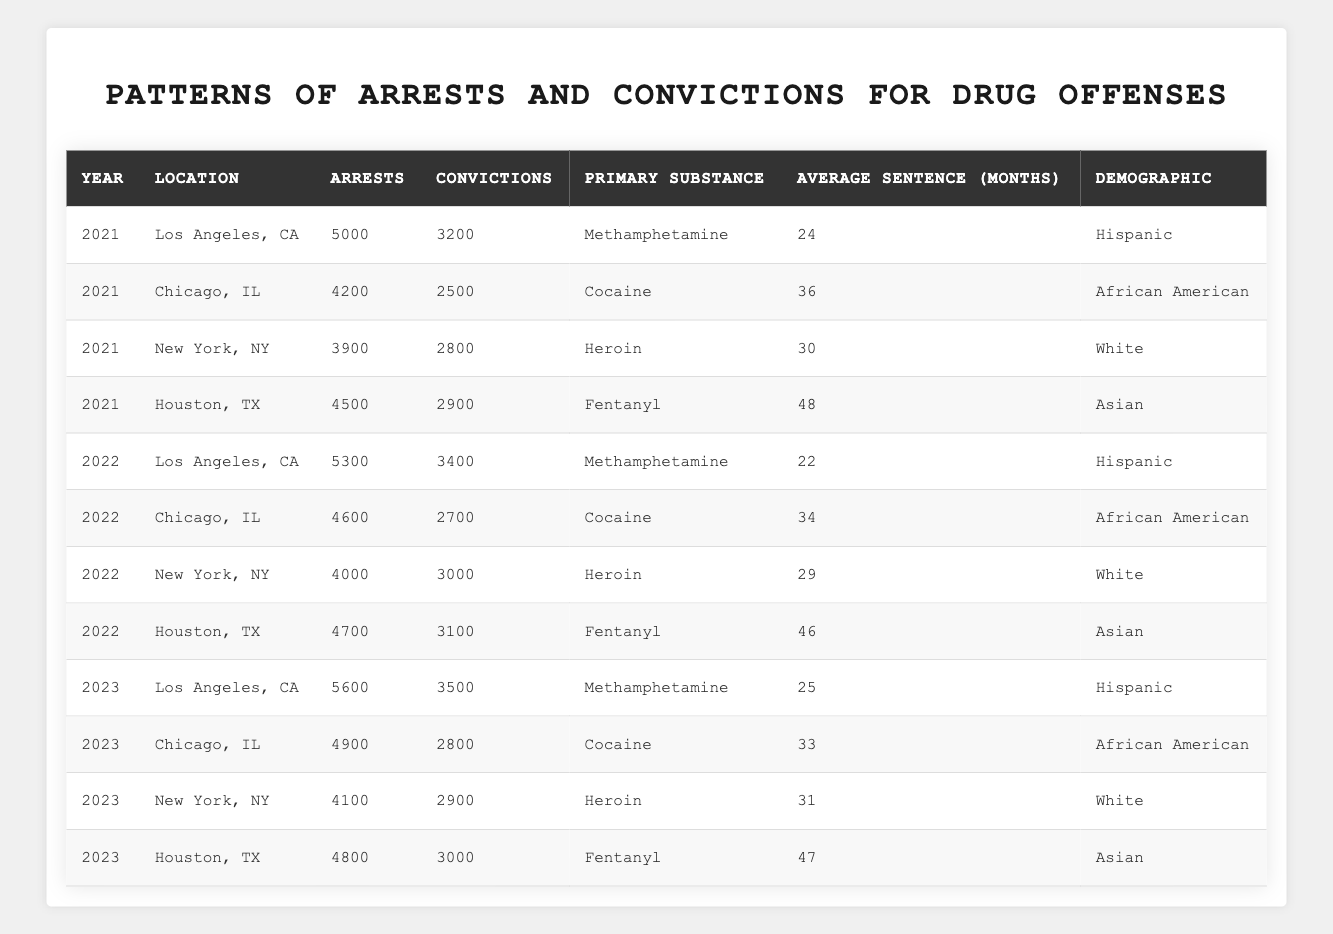What was the primary substance leading to the most arrests in 2022? In 2022, the primary substance with the highest number of arrests was Methamphetamine in Los Angeles, CA, with 5,300 arrests.
Answer: Methamphetamine What is the average sentence for drug offenses related to cocaine in Chicago over the displayed years? The average sentence for cocaine in Chicago across the years 2021 to 2023 is calculated as (36 + 34 + 33) / 3 = 34.33, rounding down gives us 34 months.
Answer: 34 months How many total arrests were made for heroin offenses in New York City from 2021 to 2023? The total arrests for heroin in New York City are 3,900 in 2021, 4,000 in 2022, and 4,100 in 2023. Adding these yields 3,900 + 4,000 + 4,100 = 12,000 arrests in total.
Answer: 12000 Which demographic had the longest average sentence for drug offenses? Asian demographic offenders related to Fentanyl received the longest average sentence of 48 months in 2021, followed by 46 months in 2022, and 47 months in 2023, averaging (48 + 46 + 47) / 3 = 47 months, which is the highest compared to others.
Answer: Asian Was there an increase or decrease in the number of overall arrests in Los Angeles from 2021 to 2023? In 2021, there were 5,000 arrests in Los Angeles, increasing to 5,600 in 2023, indicating an increase of 600 arrests over the two years.
Answer: Increase How many more convictions were there for drug offenses in Houston, TX, in 2022 compared to 2021? In Houston, TX, there were 2,900 convictions in 2021 and 3,100 in 2022. The difference is 3,100 - 2,900 = 200 more convictions in 2022 compared to 2021.
Answer: 200 more convictions What percentage of arrests led to convictions for drug offenses related to heroin in New York City in 2023? In 2023, there were 4,100 arrests and 2,900 convictions for heroin in New York City. To calculate the percentage, divide 2,900 by 4,100 and multiply by 100. Thus, (2,900 / 4,100) * 100 ≈ 70.73%, rounding gives us 71%.
Answer: 71% What was the total number of convictions across all locations for Methamphetamine in 2022? The convictions for Methamphetamine in 2022 were 3,400 in Los Angeles, and none in other locations. Therefore, the total number of convictions for Methamphetamine in 2022 is 3,400.
Answer: 3400 Which year saw the highest number of arrests in Houston for drug offenses? The arrests in Houston for drug offenses were 4,500 in 2021, 4,700 in 2022, and 4,800 in 2023. The highest number was in 2023 with 4,800 arrests.
Answer: 2023 What is the average number of arrests across all cities for Fentanyl from 2021 to 2023? The arrests for Fentanyl were 4,500 in 2021, 4,700 in 2022, and 4,800 in 2023. To find the average, we calculate (4,500 + 4,700 + 4,800) / 3 = 4,666.67, which can be rounded to 4,667.
Answer: 4667 